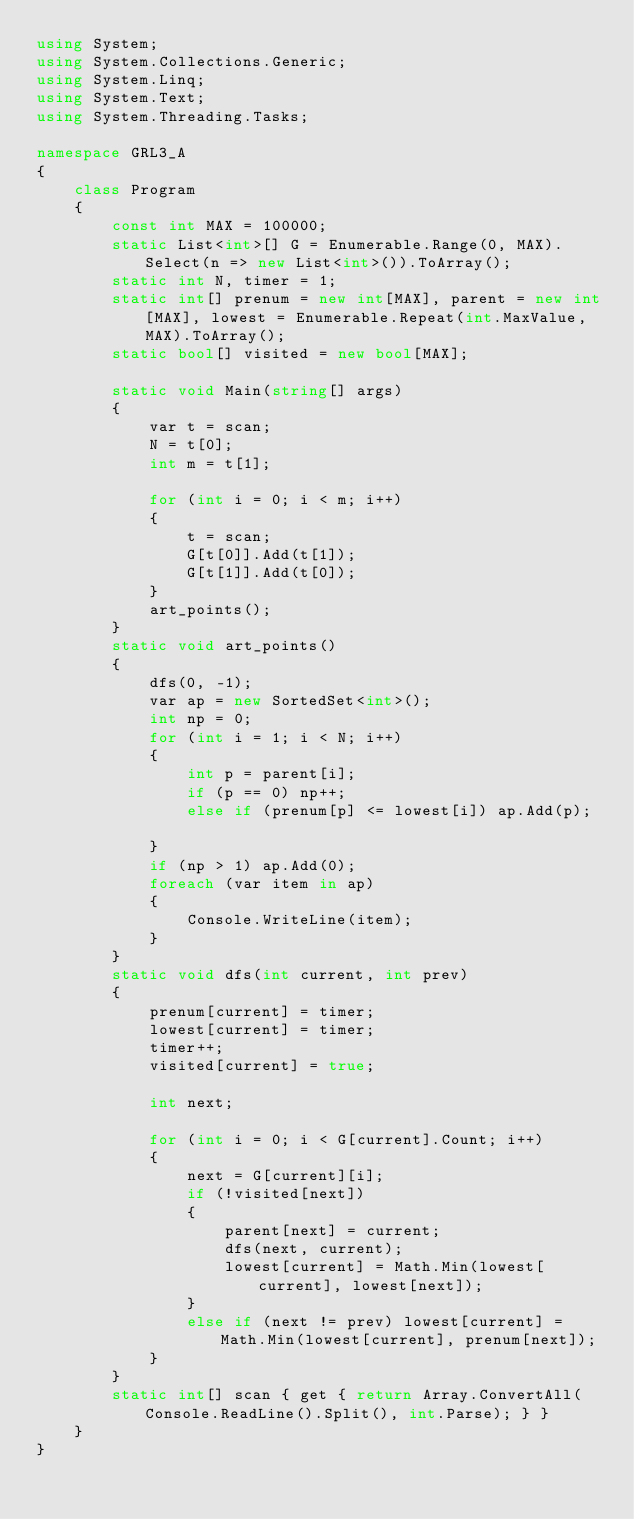<code> <loc_0><loc_0><loc_500><loc_500><_C#_>using System;
using System.Collections.Generic;
using System.Linq;
using System.Text;
using System.Threading.Tasks;

namespace GRL3_A
{
    class Program
    {
        const int MAX = 100000;
        static List<int>[] G = Enumerable.Range(0, MAX).Select(n => new List<int>()).ToArray();
        static int N, timer = 1;
        static int[] prenum = new int[MAX], parent = new int[MAX], lowest = Enumerable.Repeat(int.MaxValue,MAX).ToArray();
        static bool[] visited = new bool[MAX];

        static void Main(string[] args)
        {
            var t = scan;
            N = t[0];
            int m = t[1];

            for (int i = 0; i < m; i++)
            {
                t = scan;
                G[t[0]].Add(t[1]);
                G[t[1]].Add(t[0]);
            }
            art_points();
        }
        static void art_points()
        {
            dfs(0, -1);
            var ap = new SortedSet<int>();
            int np = 0;
            for (int i = 1; i < N; i++)
            {
                int p = parent[i];
                if (p == 0) np++;
                else if (prenum[p] <= lowest[i]) ap.Add(p);

            }
            if (np > 1) ap.Add(0);
            foreach (var item in ap)
            {
                Console.WriteLine(item);
            }
        }
        static void dfs(int current, int prev)
        {
            prenum[current] = timer;
            lowest[current] = timer;
            timer++;
            visited[current] = true;

            int next;

            for (int i = 0; i < G[current].Count; i++)
            {
                next = G[current][i];
                if (!visited[next])
                {
                    parent[next] = current;
                    dfs(next, current);
                    lowest[current] = Math.Min(lowest[current], lowest[next]);
                }
                else if (next != prev) lowest[current] = Math.Min(lowest[current], prenum[next]);
            }
        }
        static int[] scan { get { return Array.ConvertAll(Console.ReadLine().Split(), int.Parse); } }
    }
}</code> 